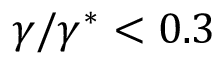<formula> <loc_0><loc_0><loc_500><loc_500>\gamma / \gamma ^ { * } < 0 . 3</formula> 